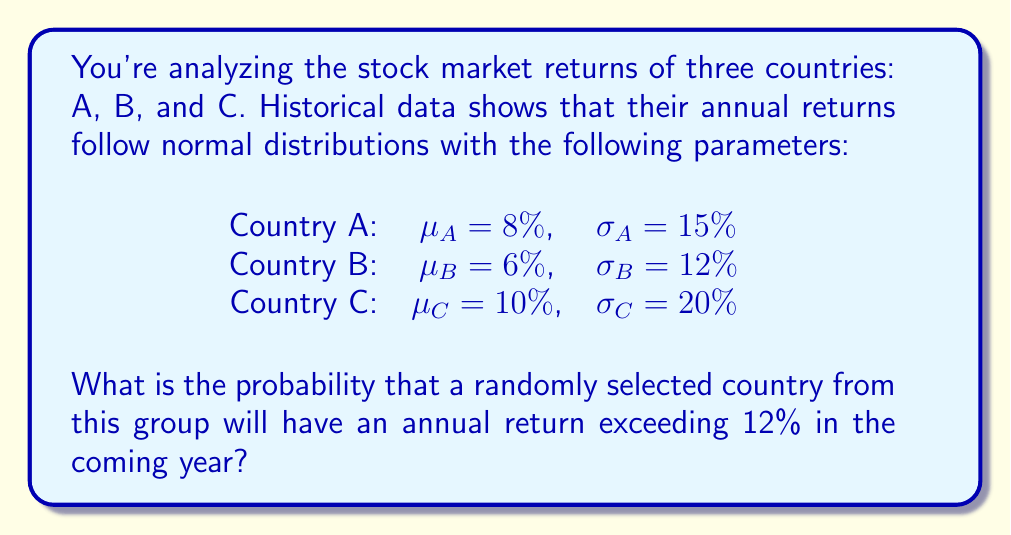Can you answer this question? To solve this problem, we'll follow these steps:

1) First, we need to calculate the probability of each country having a return exceeding 12%.

2) For each country, we'll use the z-score formula:
   $z = \frac{x - \mu}{\sigma}$
   where x is the target return (12%), μ is the mean return, and σ is the standard deviation.

3) Then, we'll use a standard normal distribution table or calculator to find P(Z > z).

4) Finally, we'll average these probabilities, as each country has an equal chance of being selected.

Calculations:

For Country A:
$z_A = \frac{12\% - 8\%}{15\%} = 0.2667$
P(Z > 0.2667) = 1 - 0.6051 = 0.3949

For Country B:
$z_B = \frac{12\% - 6\%}{12\%} = 0.5$
P(Z > 0.5) = 1 - 0.6915 = 0.3085

For Country C:
$z_C = \frac{12\% - 10\%}{20\%} = 0.1$
P(Z > 0.1) = 1 - 0.5398 = 0.4602

The probability of a randomly selected country having a return exceeding 12% is the average of these probabilities:

$P(\text{return} > 12\%) = \frac{0.3949 + 0.3085 + 0.4602}{3} = 0.3879$
Answer: 0.3879 or 38.79% 